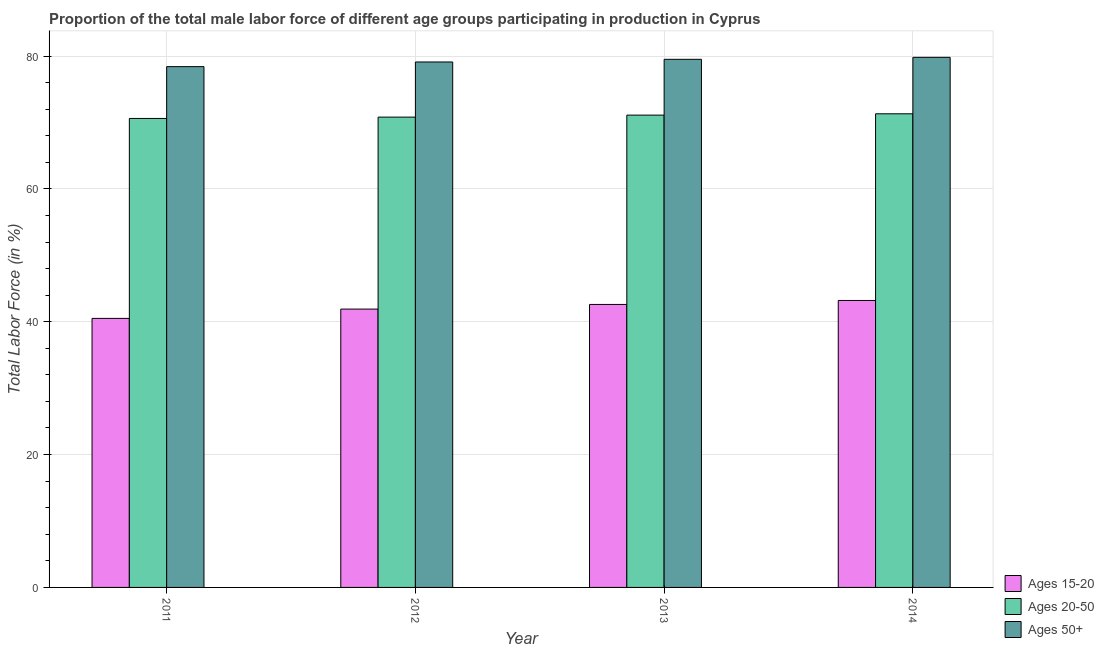How many groups of bars are there?
Provide a succinct answer. 4. Are the number of bars per tick equal to the number of legend labels?
Ensure brevity in your answer.  Yes. Are the number of bars on each tick of the X-axis equal?
Make the answer very short. Yes. How many bars are there on the 1st tick from the left?
Provide a succinct answer. 3. How many bars are there on the 1st tick from the right?
Offer a very short reply. 3. What is the label of the 1st group of bars from the left?
Keep it short and to the point. 2011. What is the percentage of male labor force within the age group 20-50 in 2014?
Offer a very short reply. 71.3. Across all years, what is the maximum percentage of male labor force within the age group 15-20?
Your answer should be very brief. 43.2. Across all years, what is the minimum percentage of male labor force within the age group 20-50?
Your response must be concise. 70.6. In which year was the percentage of male labor force within the age group 15-20 minimum?
Provide a succinct answer. 2011. What is the total percentage of male labor force within the age group 20-50 in the graph?
Offer a very short reply. 283.8. What is the difference between the percentage of male labor force within the age group 20-50 in 2013 and the percentage of male labor force above age 50 in 2011?
Keep it short and to the point. 0.5. What is the average percentage of male labor force above age 50 per year?
Your answer should be compact. 79.2. In the year 2013, what is the difference between the percentage of male labor force within the age group 20-50 and percentage of male labor force above age 50?
Offer a very short reply. 0. In how many years, is the percentage of male labor force within the age group 15-20 greater than 64 %?
Your answer should be very brief. 0. What is the ratio of the percentage of male labor force within the age group 20-50 in 2011 to that in 2012?
Your answer should be very brief. 1. What is the difference between the highest and the second highest percentage of male labor force above age 50?
Your answer should be compact. 0.3. What is the difference between the highest and the lowest percentage of male labor force within the age group 20-50?
Offer a terse response. 0.7. In how many years, is the percentage of male labor force above age 50 greater than the average percentage of male labor force above age 50 taken over all years?
Give a very brief answer. 2. Is the sum of the percentage of male labor force above age 50 in 2011 and 2012 greater than the maximum percentage of male labor force within the age group 20-50 across all years?
Your answer should be very brief. Yes. What does the 3rd bar from the left in 2013 represents?
Offer a very short reply. Ages 50+. What does the 1st bar from the right in 2013 represents?
Keep it short and to the point. Ages 50+. How many bars are there?
Your answer should be compact. 12. Are the values on the major ticks of Y-axis written in scientific E-notation?
Your response must be concise. No. Does the graph contain grids?
Provide a short and direct response. Yes. Where does the legend appear in the graph?
Make the answer very short. Bottom right. How are the legend labels stacked?
Ensure brevity in your answer.  Vertical. What is the title of the graph?
Your answer should be compact. Proportion of the total male labor force of different age groups participating in production in Cyprus. What is the label or title of the Y-axis?
Make the answer very short. Total Labor Force (in %). What is the Total Labor Force (in %) of Ages 15-20 in 2011?
Your answer should be very brief. 40.5. What is the Total Labor Force (in %) in Ages 20-50 in 2011?
Your answer should be very brief. 70.6. What is the Total Labor Force (in %) of Ages 50+ in 2011?
Make the answer very short. 78.4. What is the Total Labor Force (in %) in Ages 15-20 in 2012?
Make the answer very short. 41.9. What is the Total Labor Force (in %) of Ages 20-50 in 2012?
Give a very brief answer. 70.8. What is the Total Labor Force (in %) in Ages 50+ in 2012?
Provide a short and direct response. 79.1. What is the Total Labor Force (in %) in Ages 15-20 in 2013?
Provide a succinct answer. 42.6. What is the Total Labor Force (in %) of Ages 20-50 in 2013?
Your answer should be very brief. 71.1. What is the Total Labor Force (in %) of Ages 50+ in 2013?
Give a very brief answer. 79.5. What is the Total Labor Force (in %) in Ages 15-20 in 2014?
Offer a terse response. 43.2. What is the Total Labor Force (in %) in Ages 20-50 in 2014?
Your answer should be compact. 71.3. What is the Total Labor Force (in %) of Ages 50+ in 2014?
Offer a very short reply. 79.8. Across all years, what is the maximum Total Labor Force (in %) of Ages 15-20?
Give a very brief answer. 43.2. Across all years, what is the maximum Total Labor Force (in %) of Ages 20-50?
Your answer should be very brief. 71.3. Across all years, what is the maximum Total Labor Force (in %) of Ages 50+?
Ensure brevity in your answer.  79.8. Across all years, what is the minimum Total Labor Force (in %) in Ages 15-20?
Provide a short and direct response. 40.5. Across all years, what is the minimum Total Labor Force (in %) of Ages 20-50?
Keep it short and to the point. 70.6. Across all years, what is the minimum Total Labor Force (in %) in Ages 50+?
Offer a terse response. 78.4. What is the total Total Labor Force (in %) of Ages 15-20 in the graph?
Keep it short and to the point. 168.2. What is the total Total Labor Force (in %) of Ages 20-50 in the graph?
Your response must be concise. 283.8. What is the total Total Labor Force (in %) in Ages 50+ in the graph?
Offer a very short reply. 316.8. What is the difference between the Total Labor Force (in %) in Ages 15-20 in 2011 and that in 2012?
Keep it short and to the point. -1.4. What is the difference between the Total Labor Force (in %) in Ages 15-20 in 2011 and that in 2013?
Provide a short and direct response. -2.1. What is the difference between the Total Labor Force (in %) in Ages 15-20 in 2011 and that in 2014?
Offer a terse response. -2.7. What is the difference between the Total Labor Force (in %) of Ages 20-50 in 2011 and that in 2014?
Make the answer very short. -0.7. What is the difference between the Total Labor Force (in %) in Ages 50+ in 2011 and that in 2014?
Your response must be concise. -1.4. What is the difference between the Total Labor Force (in %) of Ages 20-50 in 2012 and that in 2013?
Make the answer very short. -0.3. What is the difference between the Total Labor Force (in %) of Ages 50+ in 2012 and that in 2014?
Ensure brevity in your answer.  -0.7. What is the difference between the Total Labor Force (in %) of Ages 15-20 in 2011 and the Total Labor Force (in %) of Ages 20-50 in 2012?
Offer a very short reply. -30.3. What is the difference between the Total Labor Force (in %) in Ages 15-20 in 2011 and the Total Labor Force (in %) in Ages 50+ in 2012?
Ensure brevity in your answer.  -38.6. What is the difference between the Total Labor Force (in %) in Ages 15-20 in 2011 and the Total Labor Force (in %) in Ages 20-50 in 2013?
Offer a terse response. -30.6. What is the difference between the Total Labor Force (in %) in Ages 15-20 in 2011 and the Total Labor Force (in %) in Ages 50+ in 2013?
Your response must be concise. -39. What is the difference between the Total Labor Force (in %) in Ages 15-20 in 2011 and the Total Labor Force (in %) in Ages 20-50 in 2014?
Offer a very short reply. -30.8. What is the difference between the Total Labor Force (in %) of Ages 15-20 in 2011 and the Total Labor Force (in %) of Ages 50+ in 2014?
Your answer should be very brief. -39.3. What is the difference between the Total Labor Force (in %) of Ages 15-20 in 2012 and the Total Labor Force (in %) of Ages 20-50 in 2013?
Your answer should be very brief. -29.2. What is the difference between the Total Labor Force (in %) of Ages 15-20 in 2012 and the Total Labor Force (in %) of Ages 50+ in 2013?
Provide a short and direct response. -37.6. What is the difference between the Total Labor Force (in %) of Ages 15-20 in 2012 and the Total Labor Force (in %) of Ages 20-50 in 2014?
Your response must be concise. -29.4. What is the difference between the Total Labor Force (in %) of Ages 15-20 in 2012 and the Total Labor Force (in %) of Ages 50+ in 2014?
Give a very brief answer. -37.9. What is the difference between the Total Labor Force (in %) in Ages 20-50 in 2012 and the Total Labor Force (in %) in Ages 50+ in 2014?
Provide a short and direct response. -9. What is the difference between the Total Labor Force (in %) in Ages 15-20 in 2013 and the Total Labor Force (in %) in Ages 20-50 in 2014?
Provide a short and direct response. -28.7. What is the difference between the Total Labor Force (in %) of Ages 15-20 in 2013 and the Total Labor Force (in %) of Ages 50+ in 2014?
Offer a very short reply. -37.2. What is the difference between the Total Labor Force (in %) in Ages 20-50 in 2013 and the Total Labor Force (in %) in Ages 50+ in 2014?
Make the answer very short. -8.7. What is the average Total Labor Force (in %) in Ages 15-20 per year?
Your response must be concise. 42.05. What is the average Total Labor Force (in %) of Ages 20-50 per year?
Keep it short and to the point. 70.95. What is the average Total Labor Force (in %) of Ages 50+ per year?
Provide a succinct answer. 79.2. In the year 2011, what is the difference between the Total Labor Force (in %) in Ages 15-20 and Total Labor Force (in %) in Ages 20-50?
Provide a short and direct response. -30.1. In the year 2011, what is the difference between the Total Labor Force (in %) in Ages 15-20 and Total Labor Force (in %) in Ages 50+?
Keep it short and to the point. -37.9. In the year 2011, what is the difference between the Total Labor Force (in %) in Ages 20-50 and Total Labor Force (in %) in Ages 50+?
Ensure brevity in your answer.  -7.8. In the year 2012, what is the difference between the Total Labor Force (in %) in Ages 15-20 and Total Labor Force (in %) in Ages 20-50?
Give a very brief answer. -28.9. In the year 2012, what is the difference between the Total Labor Force (in %) in Ages 15-20 and Total Labor Force (in %) in Ages 50+?
Offer a very short reply. -37.2. In the year 2013, what is the difference between the Total Labor Force (in %) of Ages 15-20 and Total Labor Force (in %) of Ages 20-50?
Your answer should be very brief. -28.5. In the year 2013, what is the difference between the Total Labor Force (in %) of Ages 15-20 and Total Labor Force (in %) of Ages 50+?
Your answer should be very brief. -36.9. In the year 2013, what is the difference between the Total Labor Force (in %) in Ages 20-50 and Total Labor Force (in %) in Ages 50+?
Make the answer very short. -8.4. In the year 2014, what is the difference between the Total Labor Force (in %) of Ages 15-20 and Total Labor Force (in %) of Ages 20-50?
Your answer should be compact. -28.1. In the year 2014, what is the difference between the Total Labor Force (in %) in Ages 15-20 and Total Labor Force (in %) in Ages 50+?
Ensure brevity in your answer.  -36.6. In the year 2014, what is the difference between the Total Labor Force (in %) of Ages 20-50 and Total Labor Force (in %) of Ages 50+?
Your response must be concise. -8.5. What is the ratio of the Total Labor Force (in %) in Ages 15-20 in 2011 to that in 2012?
Offer a very short reply. 0.97. What is the ratio of the Total Labor Force (in %) of Ages 50+ in 2011 to that in 2012?
Offer a very short reply. 0.99. What is the ratio of the Total Labor Force (in %) in Ages 15-20 in 2011 to that in 2013?
Ensure brevity in your answer.  0.95. What is the ratio of the Total Labor Force (in %) in Ages 20-50 in 2011 to that in 2013?
Make the answer very short. 0.99. What is the ratio of the Total Labor Force (in %) in Ages 50+ in 2011 to that in 2013?
Make the answer very short. 0.99. What is the ratio of the Total Labor Force (in %) of Ages 20-50 in 2011 to that in 2014?
Give a very brief answer. 0.99. What is the ratio of the Total Labor Force (in %) in Ages 50+ in 2011 to that in 2014?
Your response must be concise. 0.98. What is the ratio of the Total Labor Force (in %) in Ages 15-20 in 2012 to that in 2013?
Ensure brevity in your answer.  0.98. What is the ratio of the Total Labor Force (in %) in Ages 20-50 in 2012 to that in 2013?
Provide a short and direct response. 1. What is the ratio of the Total Labor Force (in %) of Ages 50+ in 2012 to that in 2013?
Your answer should be compact. 0.99. What is the ratio of the Total Labor Force (in %) in Ages 15-20 in 2012 to that in 2014?
Your response must be concise. 0.97. What is the ratio of the Total Labor Force (in %) in Ages 20-50 in 2012 to that in 2014?
Provide a succinct answer. 0.99. What is the ratio of the Total Labor Force (in %) in Ages 15-20 in 2013 to that in 2014?
Provide a short and direct response. 0.99. What is the ratio of the Total Labor Force (in %) in Ages 20-50 in 2013 to that in 2014?
Offer a very short reply. 1. What is the ratio of the Total Labor Force (in %) of Ages 50+ in 2013 to that in 2014?
Your response must be concise. 1. What is the difference between the highest and the lowest Total Labor Force (in %) in Ages 15-20?
Provide a short and direct response. 2.7. What is the difference between the highest and the lowest Total Labor Force (in %) of Ages 20-50?
Your answer should be very brief. 0.7. What is the difference between the highest and the lowest Total Labor Force (in %) of Ages 50+?
Offer a terse response. 1.4. 